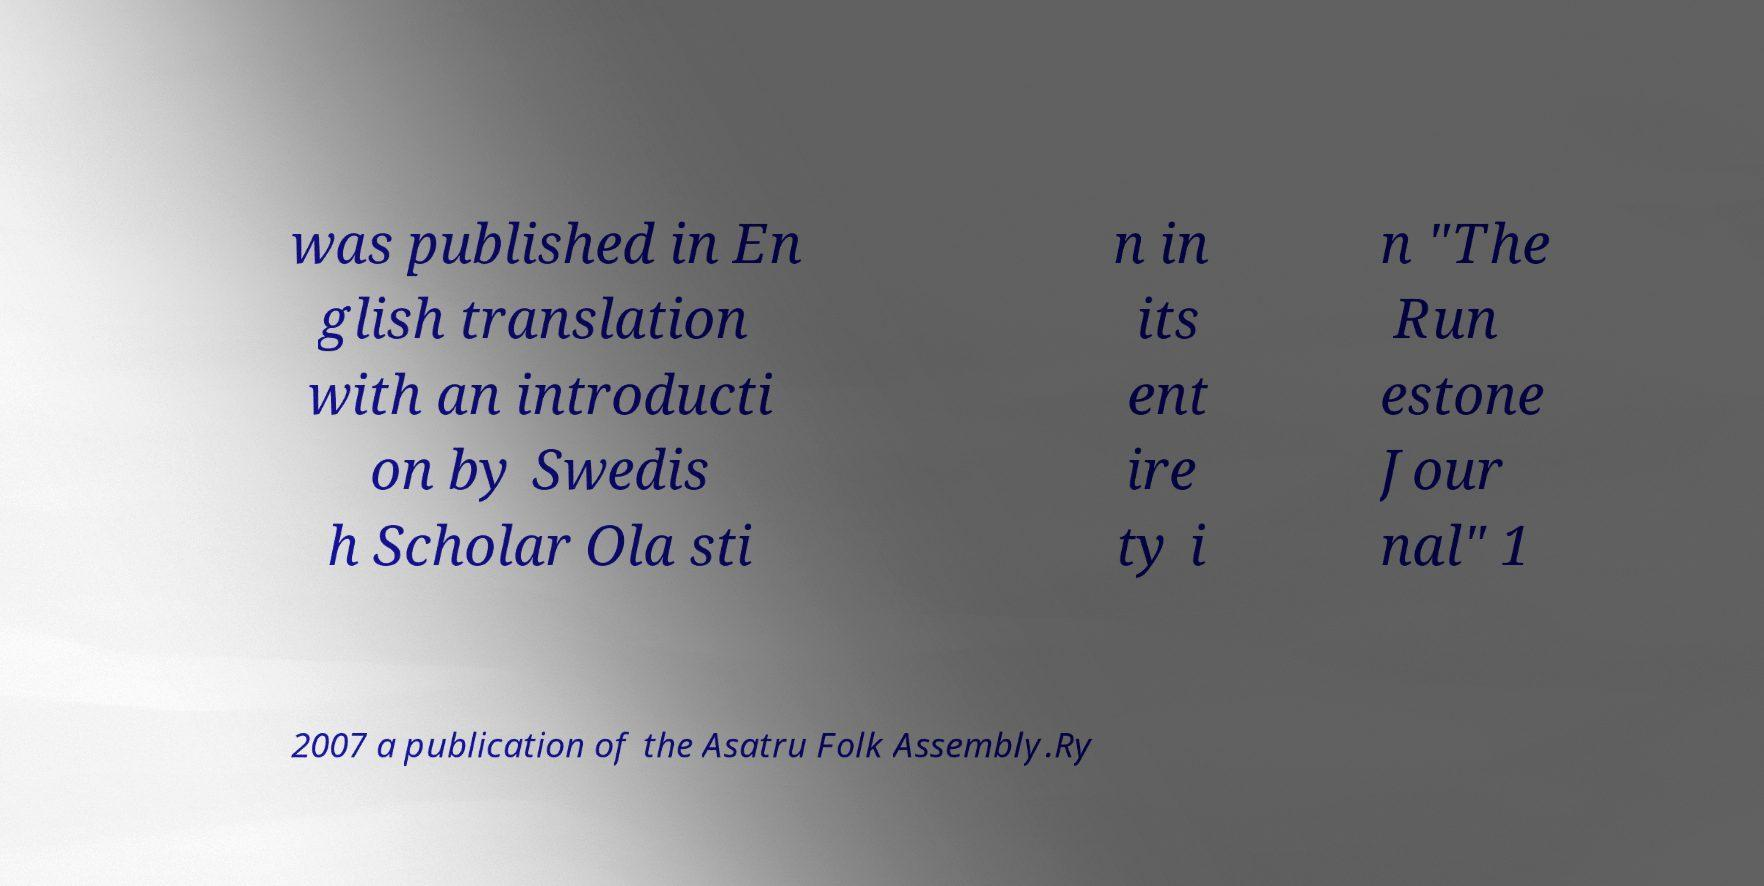Could you extract and type out the text from this image? was published in En glish translation with an introducti on by Swedis h Scholar Ola sti n in its ent ire ty i n "The Run estone Jour nal" 1 2007 a publication of the Asatru Folk Assembly.Ry 